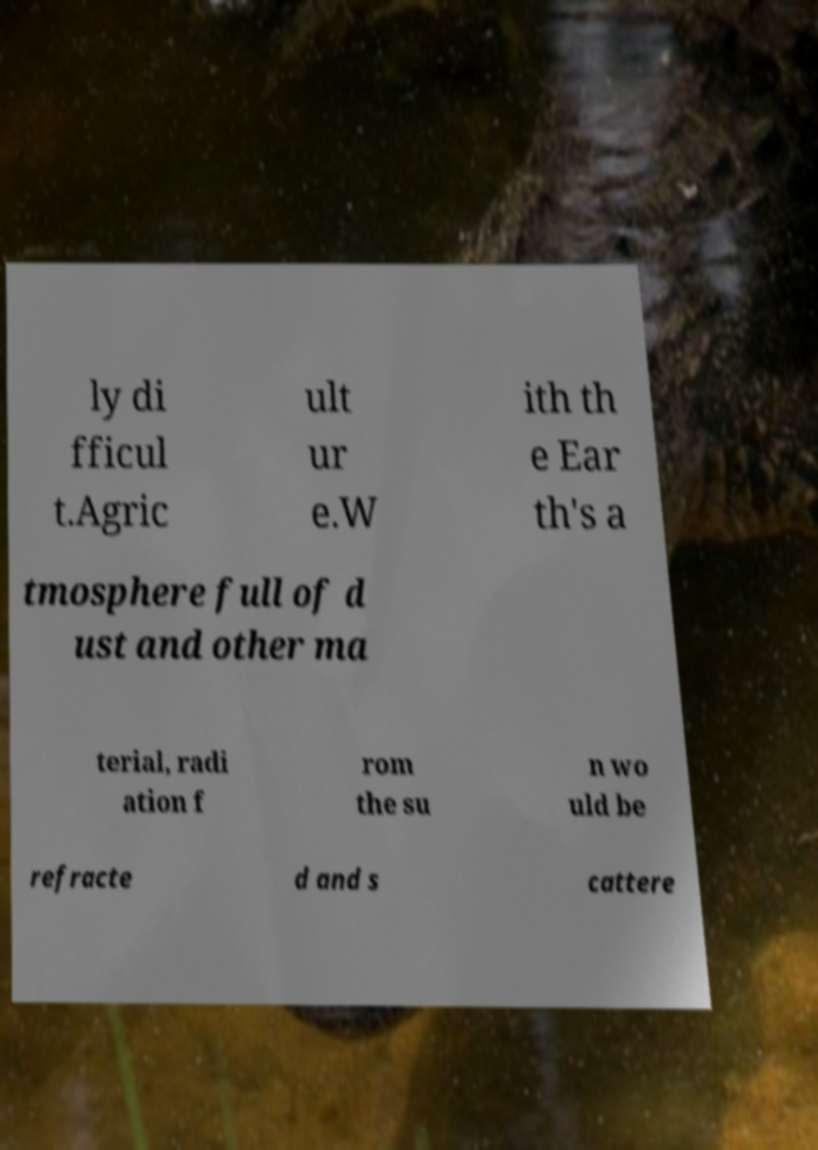Can you accurately transcribe the text from the provided image for me? ly di fficul t.Agric ult ur e.W ith th e Ear th's a tmosphere full of d ust and other ma terial, radi ation f rom the su n wo uld be refracte d and s cattere 